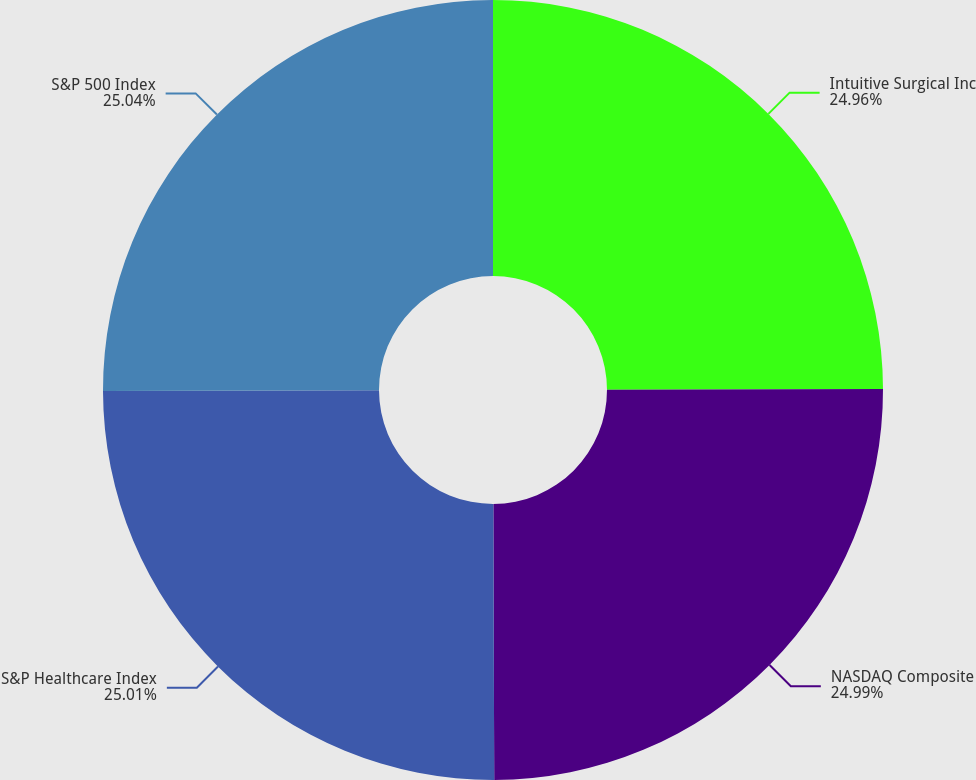<chart> <loc_0><loc_0><loc_500><loc_500><pie_chart><fcel>Intuitive Surgical Inc<fcel>NASDAQ Composite<fcel>S&P Healthcare Index<fcel>S&P 500 Index<nl><fcel>24.96%<fcel>24.99%<fcel>25.01%<fcel>25.04%<nl></chart> 